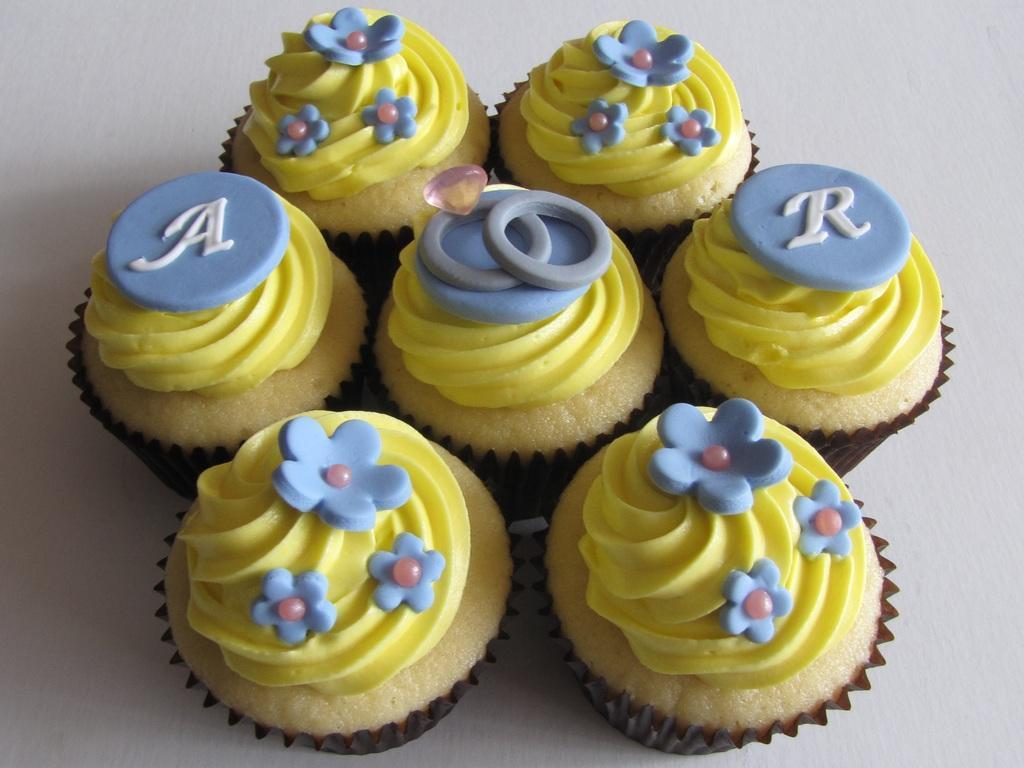Can you describe this image briefly? In this picture we can see few muffins. 